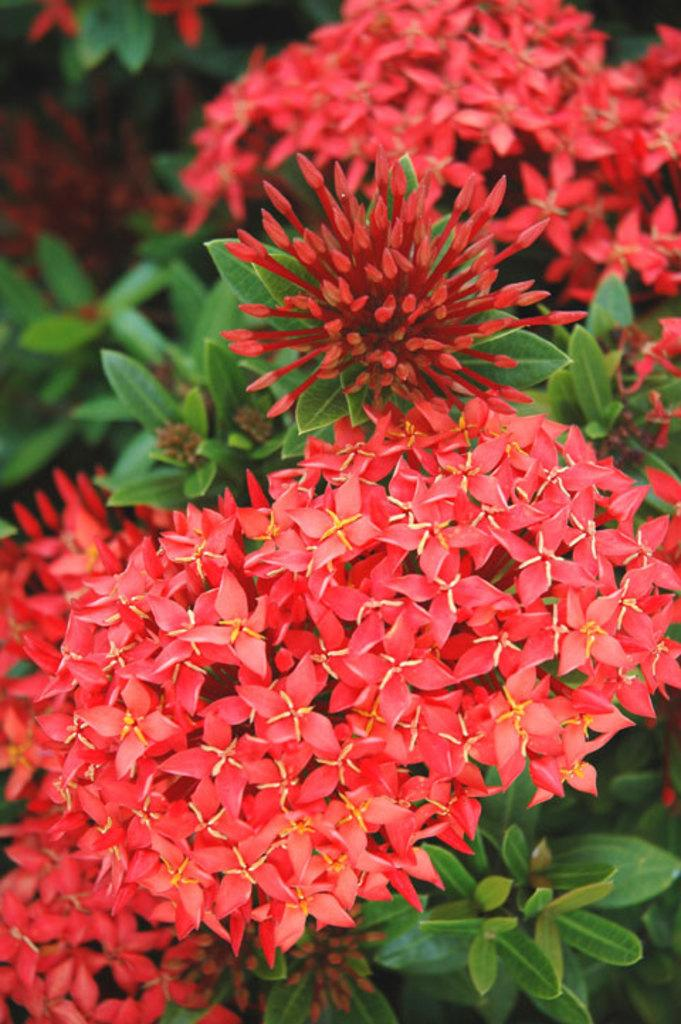What type of living organisms can be seen in the image? Flowers and plants can be seen in the image. Can you describe the plants in the image? The plants in the image are flowers. How many hands are visible in the image? There are no hands visible in the image; it features flowers and plants. What type of metal is used to make the flowers in the image? The flowers in the image are not made of metal; they are living organisms. 